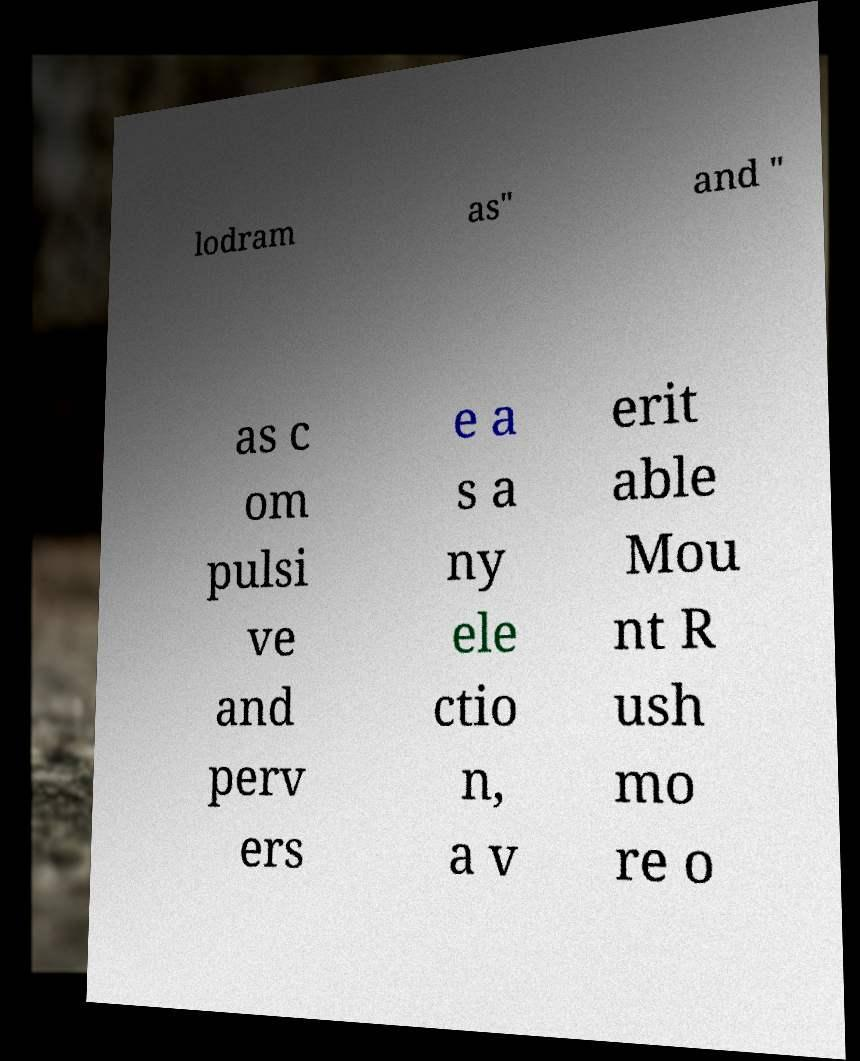There's text embedded in this image that I need extracted. Can you transcribe it verbatim? lodram as" and " as c om pulsi ve and perv ers e a s a ny ele ctio n, a v erit able Mou nt R ush mo re o 